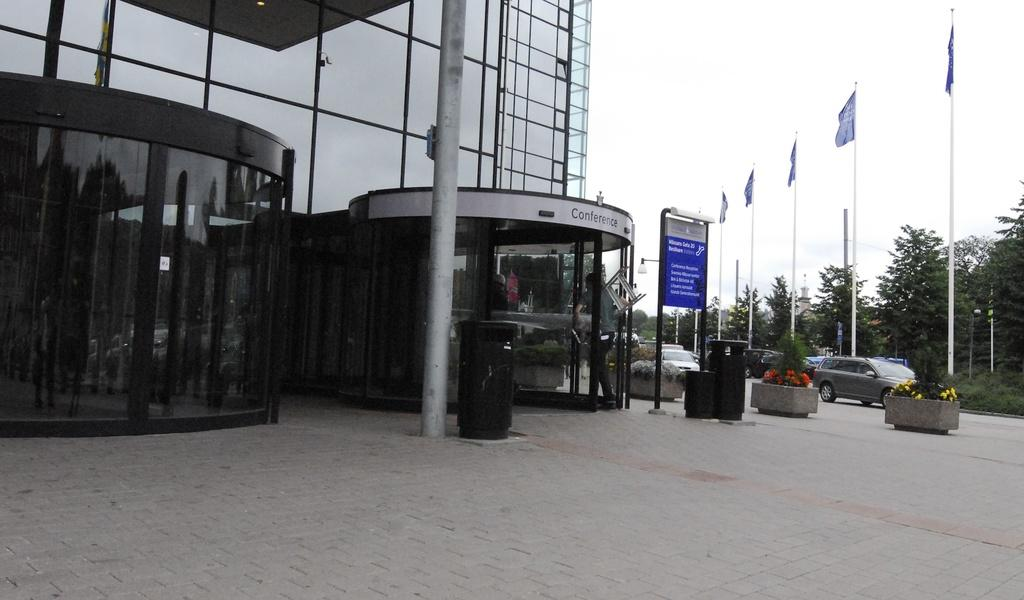What type of building is on the left side of the image? There is a building covered with glass panels on the left side of the image. What can be seen on the road in the image? Vehicles are present on the road in the image. What is visible in the background of the image? Trees and flags are visible in the background of the image. What part of the natural environment is visible in the image? The sky is visible in the image. What type of stocking is being used to care for the dogs in the image? There are no dogs or stockings present in the image. 